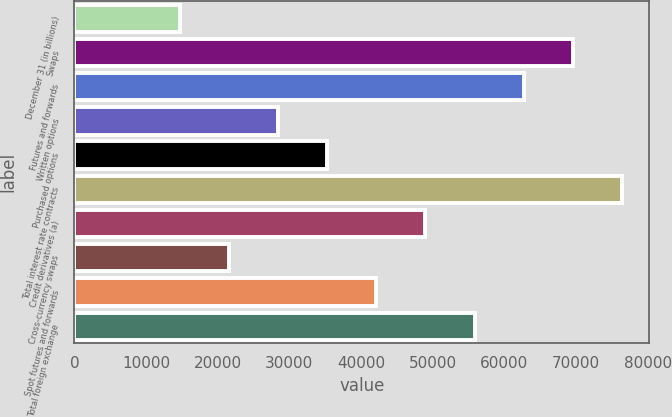Convert chart to OTSL. <chart><loc_0><loc_0><loc_500><loc_500><bar_chart><fcel>December 31 (in billions)<fcel>Swaps<fcel>Futures and forwards<fcel>Written options<fcel>Purchased options<fcel>Total interest rate contracts<fcel>Credit derivatives (a)<fcel>Cross-currency swaps<fcel>Spot futures and forwards<fcel>Total foreign exchange<nl><fcel>14732.4<fcel>69550<fcel>62697.8<fcel>28436.8<fcel>35289<fcel>76402.2<fcel>48993.4<fcel>21584.6<fcel>42141.2<fcel>55845.6<nl></chart> 